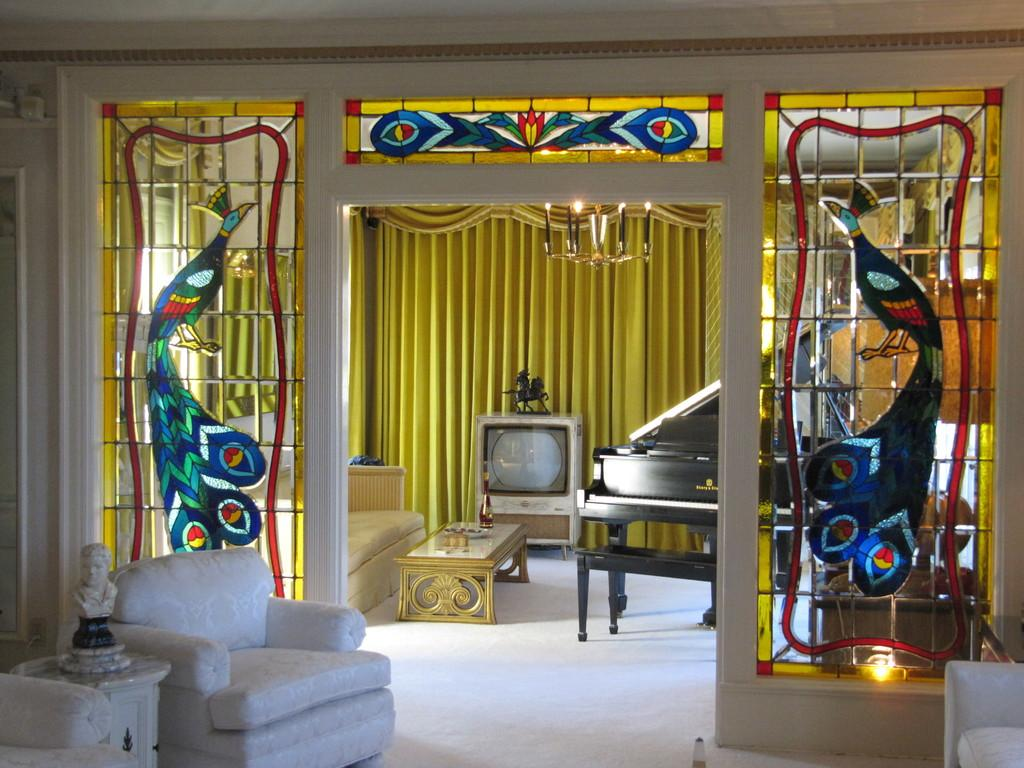What type of furniture is present in the image? There are chairs and a sofa bed in the image. What type of entertainment device is present in the image? There is a television in the image. What type of musical instrument is present in the image? There is a piano in the image. What type of object is present on a table in the image? There is a toy on a table in the image. What type of basket is present in the image? There is no basket present in the image. How do the friends feel about the piano in the image? The image does not depict any friends or their feelings, so we cannot determine how they feel about the piano. 